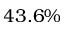<formula> <loc_0><loc_0><loc_500><loc_500>4 3 . 6 \%</formula> 